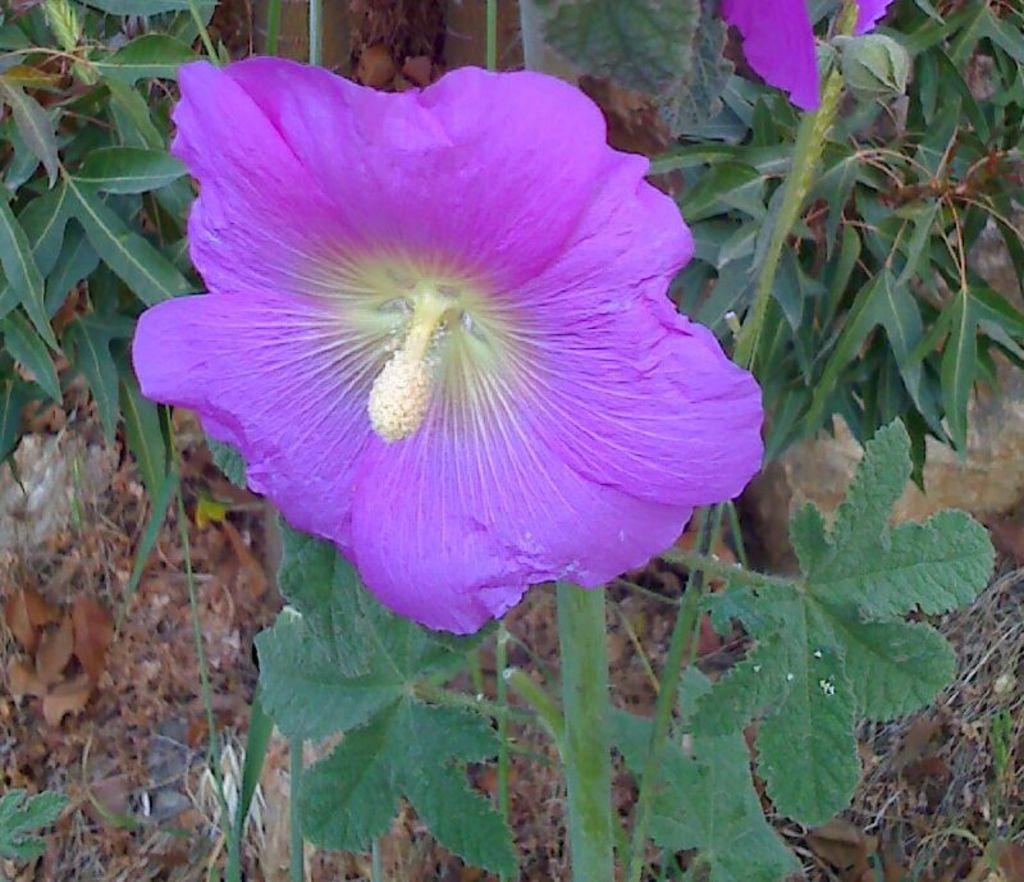Please provide a concise description of this image. In this image I can see a flower. There are leaves in the background and there are dried leaves on the ground. 